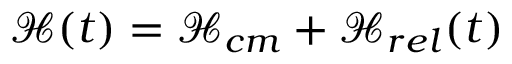<formula> <loc_0><loc_0><loc_500><loc_500>\mathcal { H } ( t ) = \mathcal { H } _ { c m } + \mathcal { H } _ { r e l } ( t )</formula> 